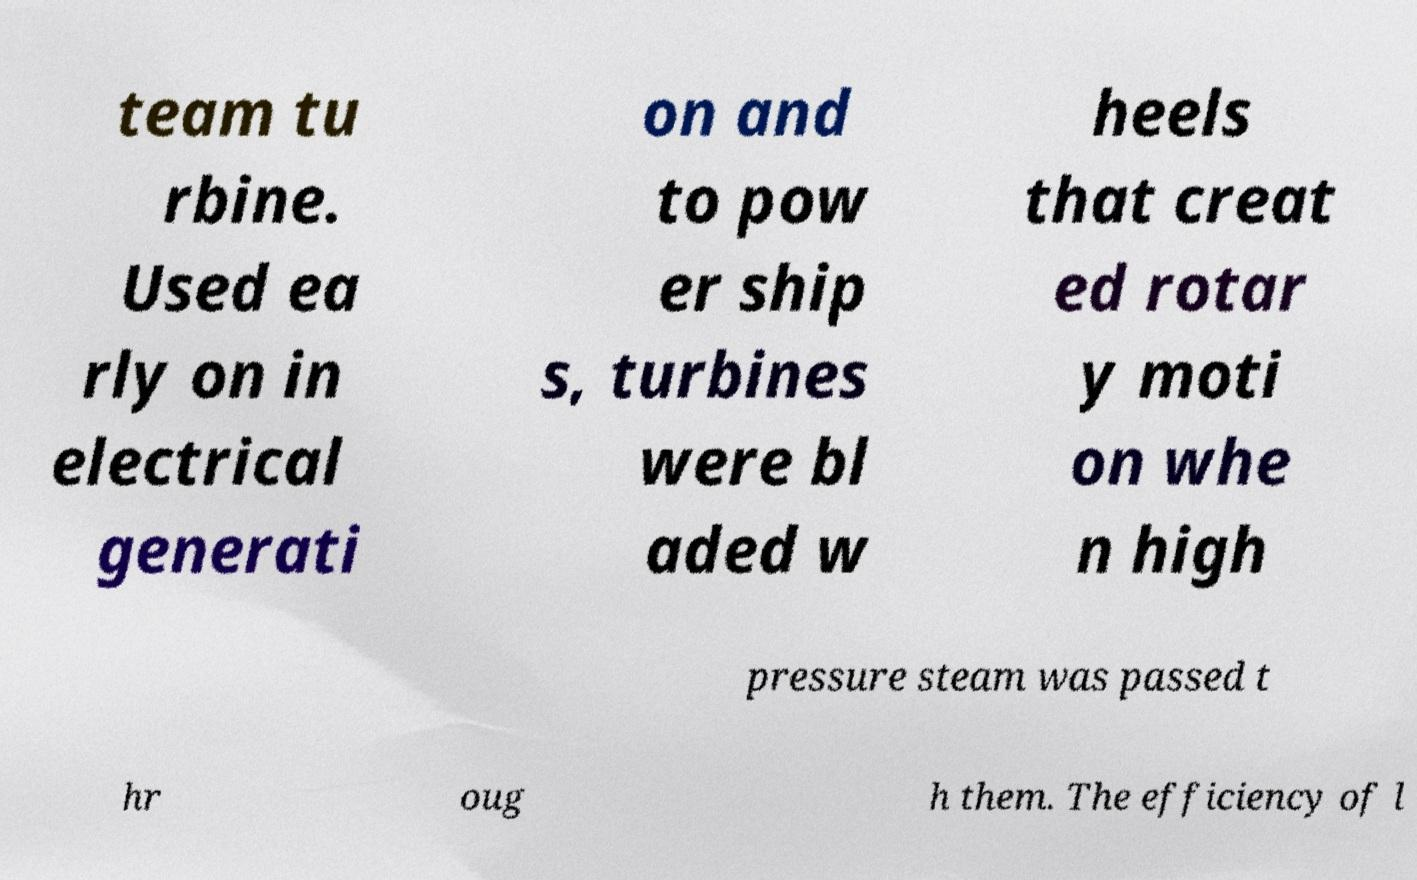What messages or text are displayed in this image? I need them in a readable, typed format. team tu rbine. Used ea rly on in electrical generati on and to pow er ship s, turbines were bl aded w heels that creat ed rotar y moti on whe n high pressure steam was passed t hr oug h them. The efficiency of l 